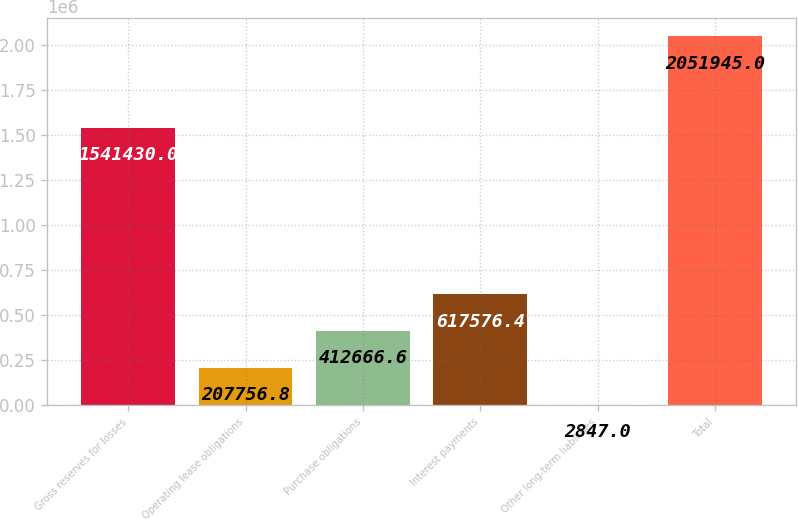Convert chart to OTSL. <chart><loc_0><loc_0><loc_500><loc_500><bar_chart><fcel>Gross reserves for losses<fcel>Operating lease obligations<fcel>Purchase obligations<fcel>Interest payments<fcel>Other long-term liabilities<fcel>Total<nl><fcel>1.54143e+06<fcel>207757<fcel>412667<fcel>617576<fcel>2847<fcel>2.05194e+06<nl></chart> 